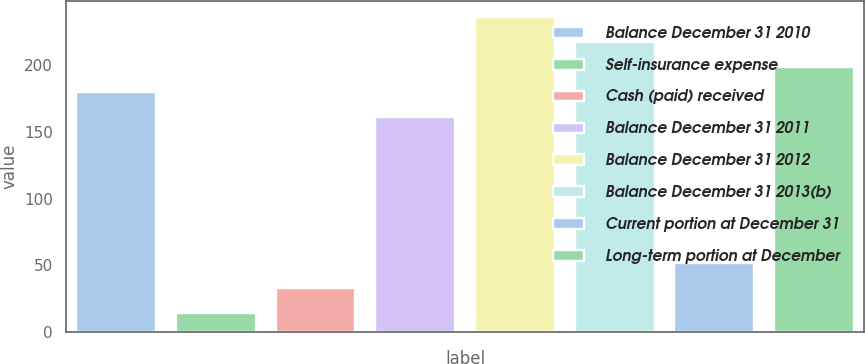<chart> <loc_0><loc_0><loc_500><loc_500><bar_chart><fcel>Balance December 31 2010<fcel>Self-insurance expense<fcel>Cash (paid) received<fcel>Balance December 31 2011<fcel>Balance December 31 2012<fcel>Balance December 31 2013(b)<fcel>Current portion at December 31<fcel>Long-term portion at December<nl><fcel>179.8<fcel>14<fcel>32.8<fcel>161<fcel>236.2<fcel>217.4<fcel>51.6<fcel>198.6<nl></chart> 